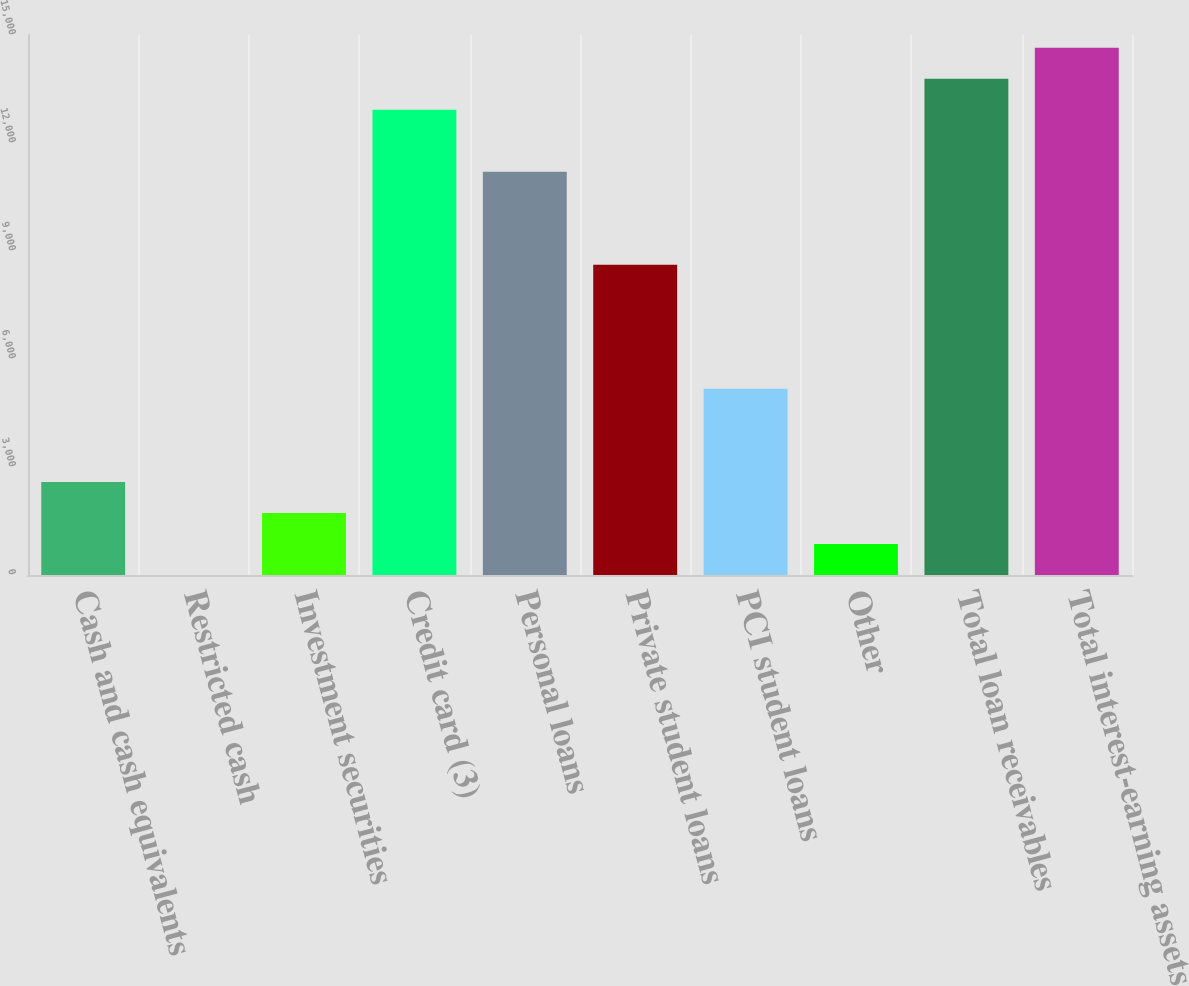Convert chart. <chart><loc_0><loc_0><loc_500><loc_500><bar_chart><fcel>Cash and cash equivalents<fcel>Restricted cash<fcel>Investment securities<fcel>Credit card (3)<fcel>Personal loans<fcel>Private student loans<fcel>PCI student loans<fcel>Other<fcel>Total loan receivables<fcel>Total interest-earning assets<nl><fcel>2586.2<fcel>2<fcel>1724.8<fcel>12923<fcel>11200.2<fcel>8616<fcel>5170.4<fcel>863.4<fcel>13784.4<fcel>14645.8<nl></chart> 